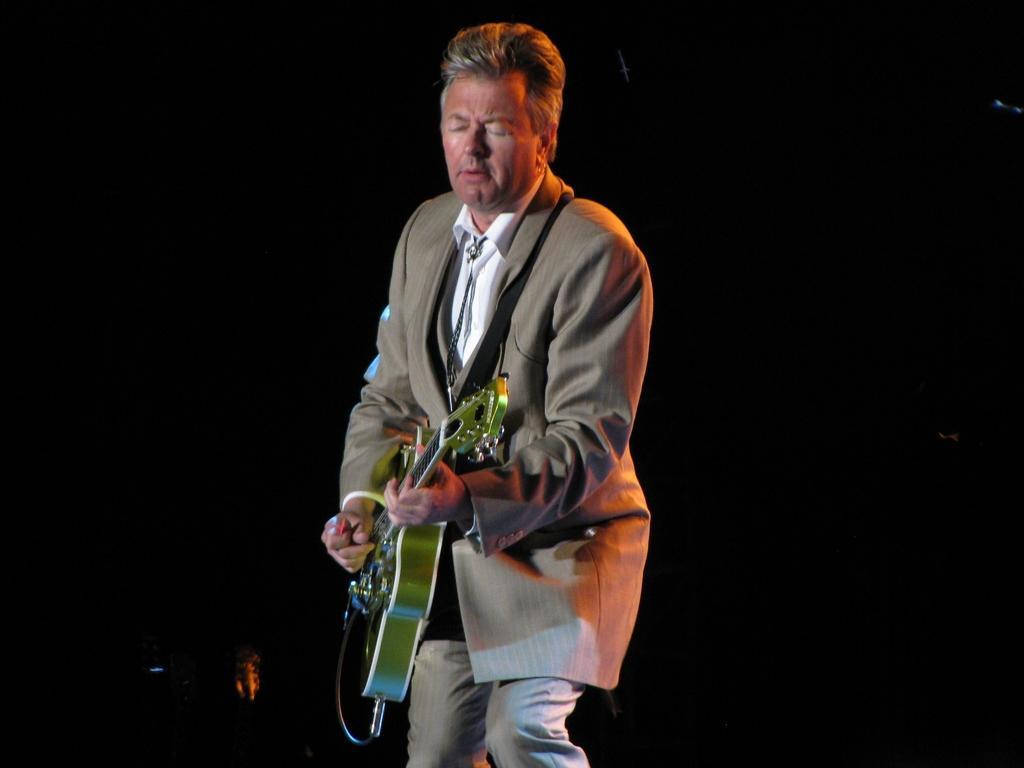Could you give a brief overview of what you see in this image? In this picture I can see there is a man standing and wearing a blazer on cream color and he is holding a guitar it is in green color and there is a cable connected to it. The man is playing the guitar. 